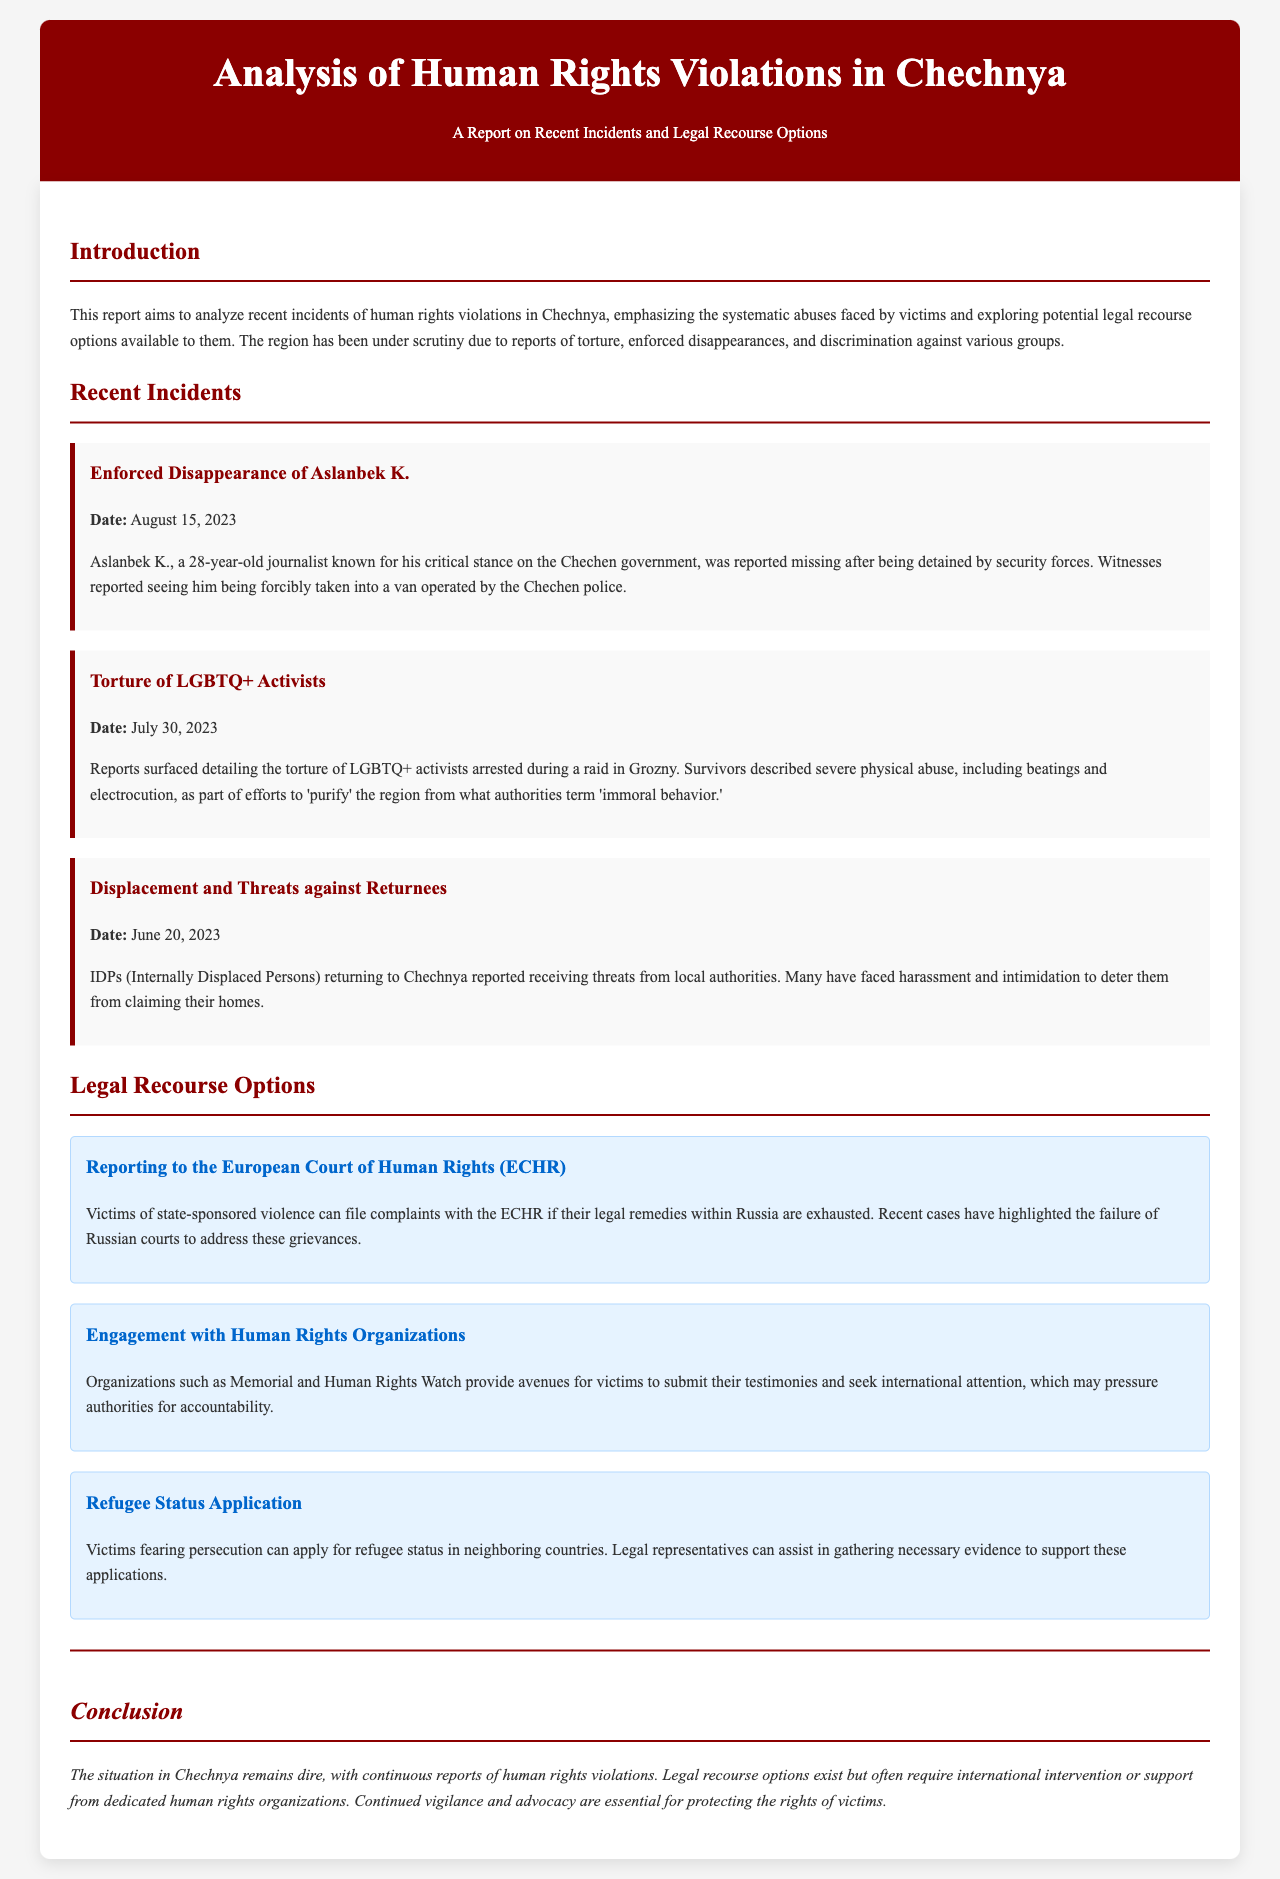What is the date of the enforced disappearance of Aslanbek K.? The report states the specific date of the incident, which is August 15, 2023.
Answer: August 15, 2023 What type of abuse did LGBTQ+ activists face? The report describes the abuse as severe physical abuse, including beatings and electrocution, during a raid in Grozny.
Answer: Torture What is one of the legal recourse options available for victims? The document lists multiple options, one of which is to report to the European Court of Human Rights after exhausting local remedies.
Answer: Reporting to the European Court of Human Rights Who are the organizations mentioned that assist victims? The report mentions organizations that provide avenues for victims, specifically Memorial and Human Rights Watch.
Answer: Memorial and Human Rights Watch What is the common theme among the incidents reported? The incidents highlight systematic abuses faced by victims in the region related to state-sponsored violence.
Answer: Systematic abuses 